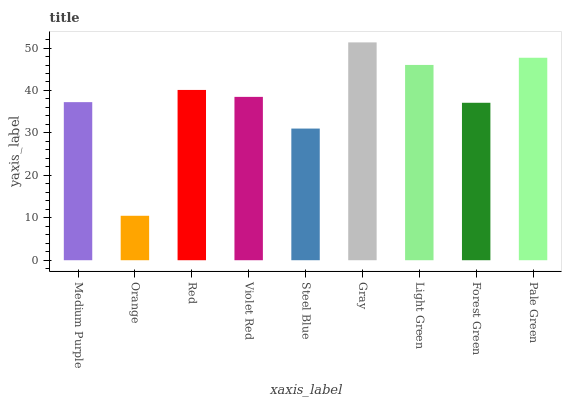Is Orange the minimum?
Answer yes or no. Yes. Is Gray the maximum?
Answer yes or no. Yes. Is Red the minimum?
Answer yes or no. No. Is Red the maximum?
Answer yes or no. No. Is Red greater than Orange?
Answer yes or no. Yes. Is Orange less than Red?
Answer yes or no. Yes. Is Orange greater than Red?
Answer yes or no. No. Is Red less than Orange?
Answer yes or no. No. Is Violet Red the high median?
Answer yes or no. Yes. Is Violet Red the low median?
Answer yes or no. Yes. Is Gray the high median?
Answer yes or no. No. Is Orange the low median?
Answer yes or no. No. 